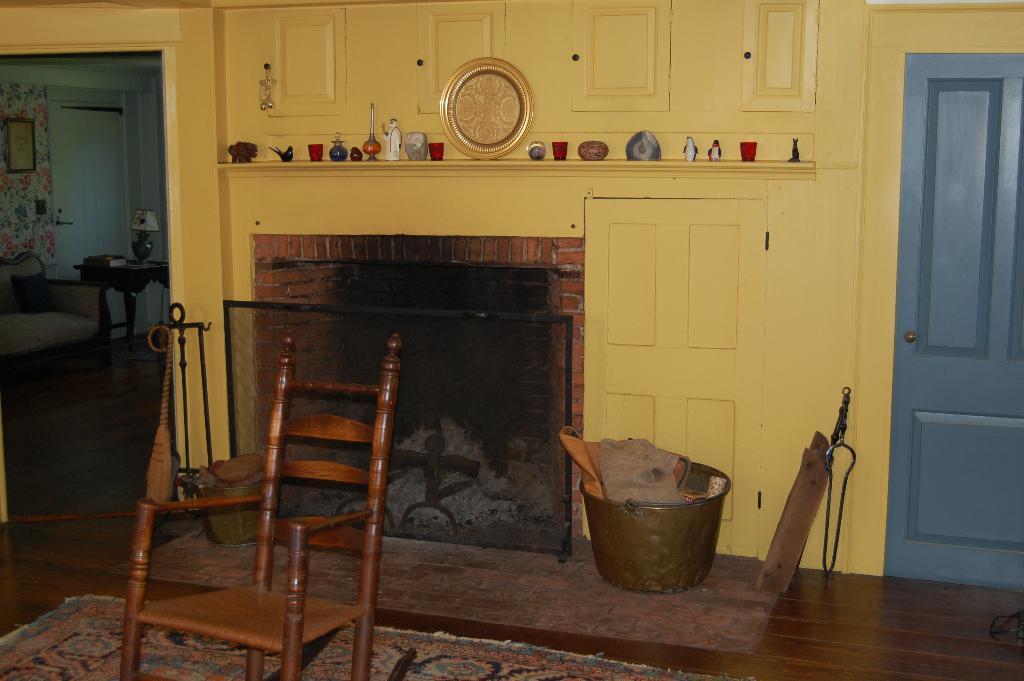In one or two sentences, can you explain what this image depicts? There is a cupboard on the center. There is a toys and shield on a cupboard. There is a door,bowl and wooden stick on the right side. There is another door and chair on the left side. 